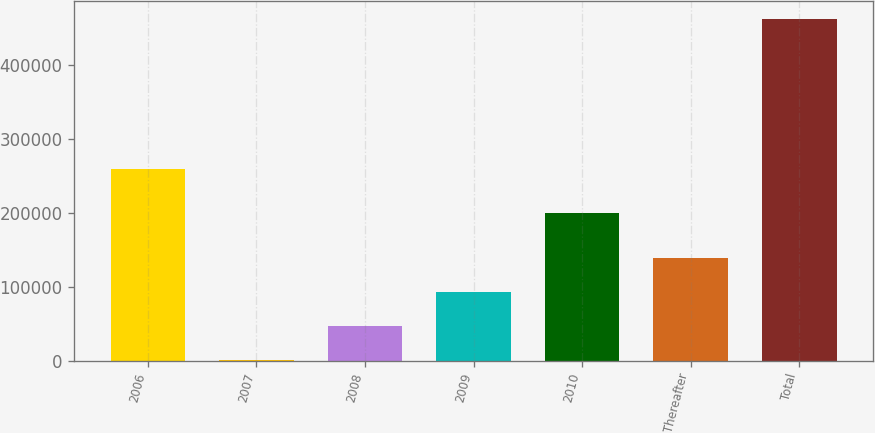Convert chart to OTSL. <chart><loc_0><loc_0><loc_500><loc_500><bar_chart><fcel>2006<fcel>2007<fcel>2008<fcel>2009<fcel>2010<fcel>Thereafter<fcel>Total<nl><fcel>259977<fcel>214<fcel>46506.7<fcel>92799.4<fcel>200353<fcel>139092<fcel>463141<nl></chart> 